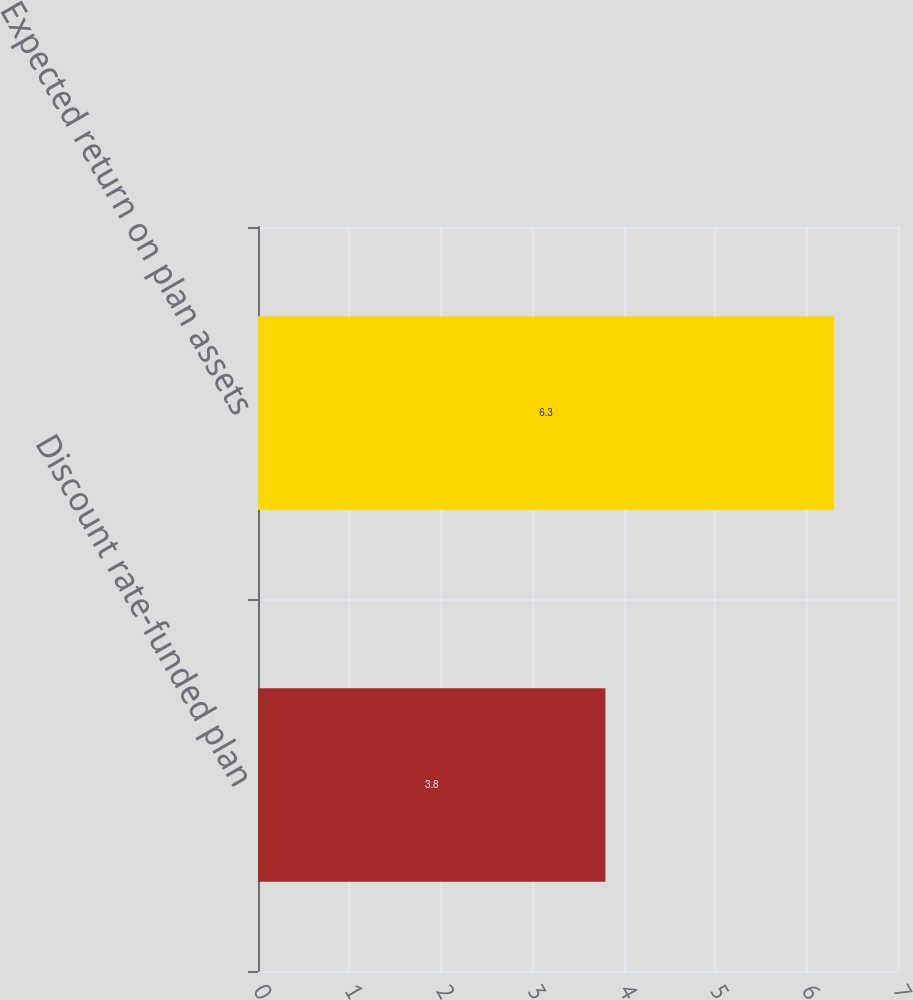Convert chart. <chart><loc_0><loc_0><loc_500><loc_500><bar_chart><fcel>Discount rate-funded plan<fcel>Expected return on plan assets<nl><fcel>3.8<fcel>6.3<nl></chart> 